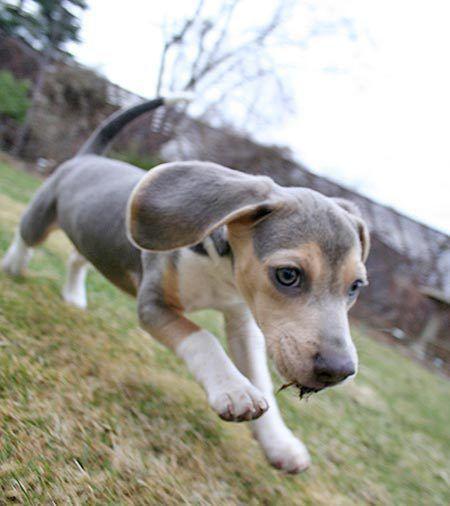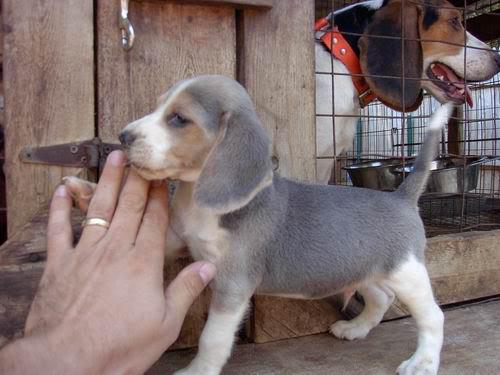The first image is the image on the left, the second image is the image on the right. Assess this claim about the two images: "Each image contains one hound dog posing on furniture, and at least one dog is on leather upholstery.". Correct or not? Answer yes or no. No. 